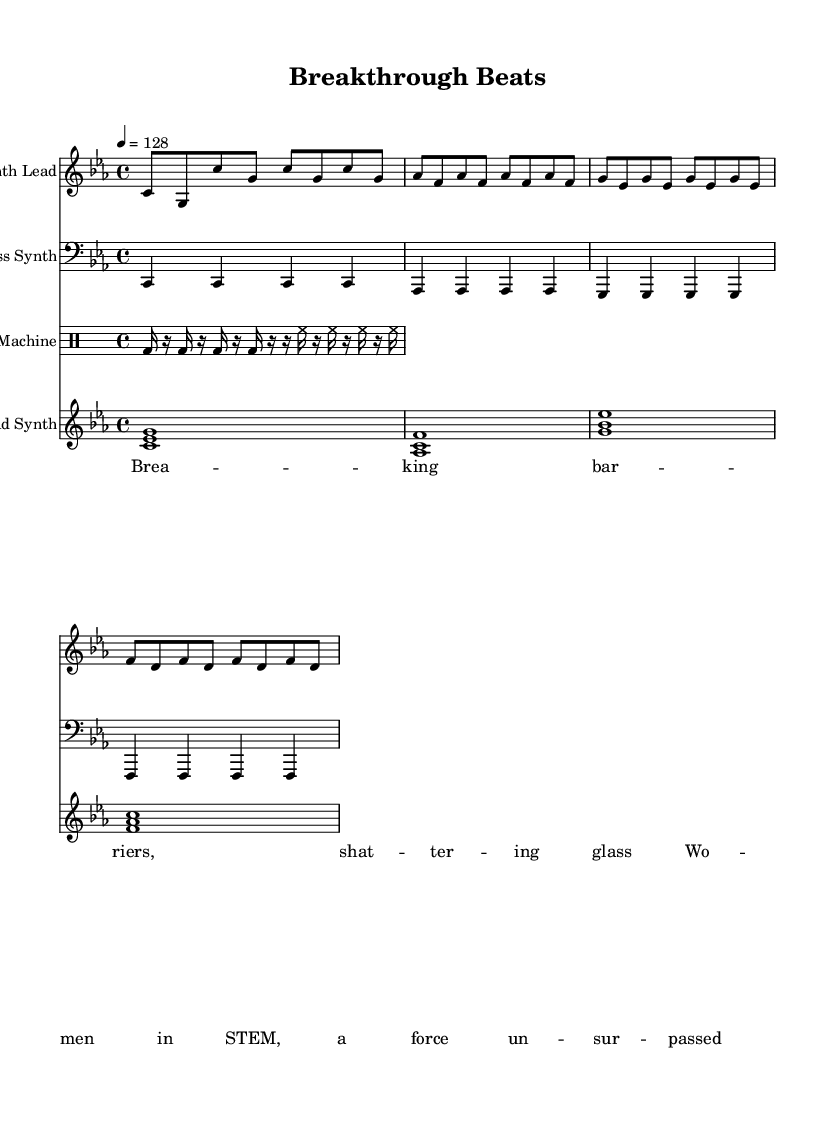What is the key signature of this music? The key signature is C minor, which is indicated by the presence of three flats: B flat, E flat, and A flat.
Answer: C minor What is the time signature of this music? The time signature is indicated at the beginning of the score and shows four beats in a measure, which is represented as 4/4.
Answer: 4/4 What is the tempo of this piece? The tempo is specified with a number indicating beats per minute, set at a quarter note equals 128 beats per minute.
Answer: 128 How many measures are in the synth lead section? The synth lead consists of four measures, which can be counted based on the grouping of notes and rests shown in the part.
Answer: 4 What instrument plays the bass synth? The bass synth is specifically notated in the score and is played with the clef indicating a bass instrument, confirming it's played on bass.
Answer: Bass Synth What is the rhythmic pattern of the drum machine? The drum machine alternates between bass drum and hi-hat sounds, indicated by specific rhythmic notation that shows a sequence of sixteen notes and rests.
Answer: Bass drum and hi-hat What are the opening lyrics of the song? The lyrics section contains the text that accompanies the music, and the very first words indicate what is celebrated in the song.
Answer: Breaking barriers 